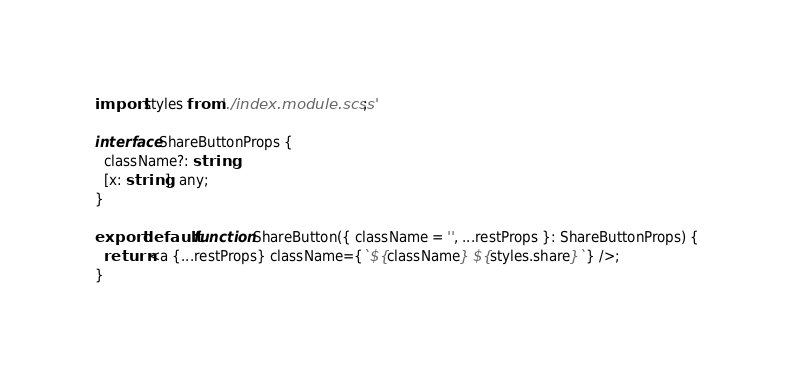<code> <loc_0><loc_0><loc_500><loc_500><_TypeScript_>import styles from './index.module.scss';

interface ShareButtonProps {
  className?: string;
  [x: string]: any;
}

export default function ShareButton({ className = '', ...restProps }: ShareButtonProps) {
  return <a {...restProps} className={`${className} ${styles.share}`} />;
}
</code> 